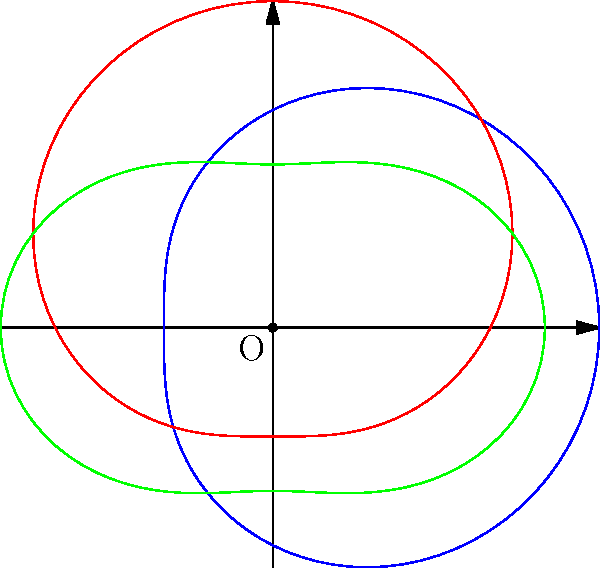In the context of the Belt and Road Initiative, the polar graph represents trade agreements between China, ASEAN, and the EU. The overlapping areas indicate shared trade benefits. Which two entities have the largest area of shared benefits, and what does this imply for China's trade strategy? To answer this question, we need to analyze the polar graph and its implications:

1. The blue curve represents China's trade agreement.
2. The red curve represents ASEAN's trade agreement.
3. The green curve represents the EU's trade agreement.

Step 1: Observe the overlapping areas
- China-ASEAN (blue-red): Large overlap
- China-EU (blue-green): Moderate overlap
- ASEAN-EU (red-green): Smaller overlap

Step 2: Compare the overlapping areas
The largest overlapping area is between the blue (China) and red (ASEAN) curves.

Step 3: Interpret the implications
- The large overlap between China and ASEAN indicates strong shared trade benefits.
- This suggests that China's trade strategy in the Belt and Road Initiative should prioritize strengthening ties with ASEAN countries.

Step 4: Consider the diplomatic context
As a Chinese ambassador promoting the Belt and Road Initiative, this information suggests focusing diplomatic efforts on ASEAN countries to maximize mutual benefits and expand trade cooperation.
Answer: China and ASEAN; prioritize ASEAN relations in BRI strategy. 